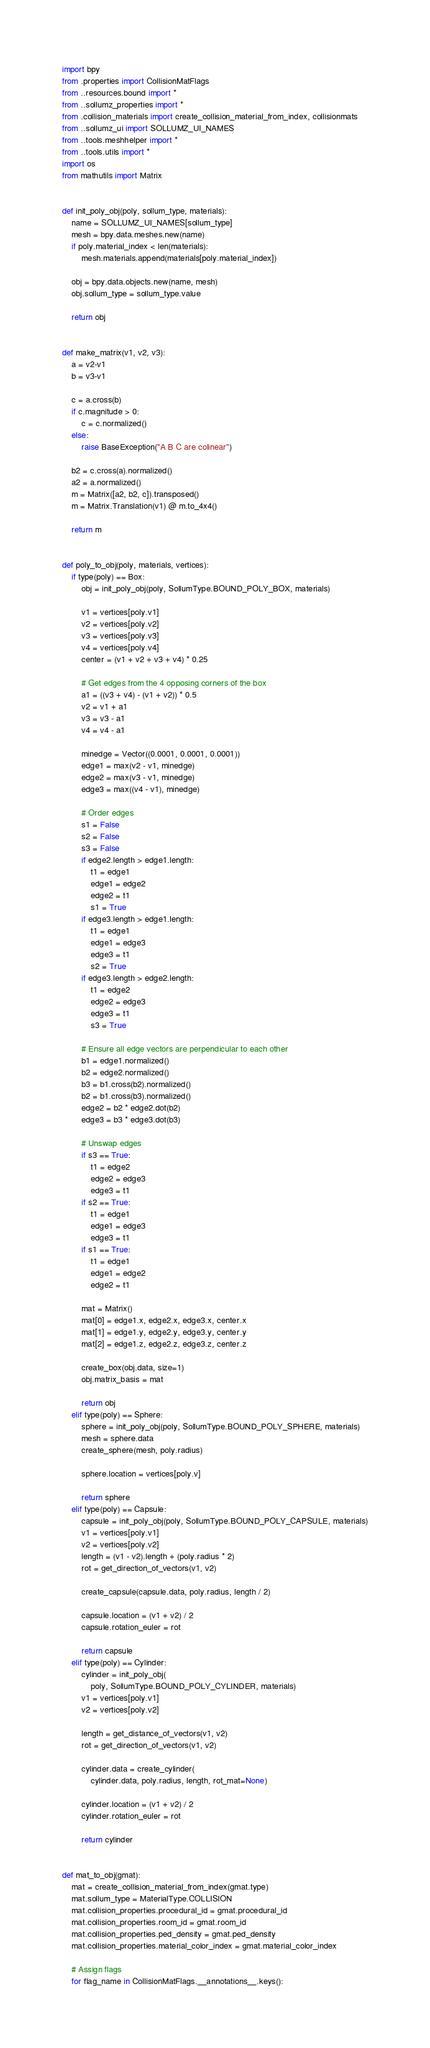<code> <loc_0><loc_0><loc_500><loc_500><_Python_>import bpy
from .properties import CollisionMatFlags
from ..resources.bound import *
from ..sollumz_properties import *
from .collision_materials import create_collision_material_from_index, collisionmats
from ..sollumz_ui import SOLLUMZ_UI_NAMES
from ..tools.meshhelper import *
from ..tools.utils import *
import os
from mathutils import Matrix


def init_poly_obj(poly, sollum_type, materials):
    name = SOLLUMZ_UI_NAMES[sollum_type]
    mesh = bpy.data.meshes.new(name)
    if poly.material_index < len(materials):
        mesh.materials.append(materials[poly.material_index])

    obj = bpy.data.objects.new(name, mesh)
    obj.sollum_type = sollum_type.value

    return obj


def make_matrix(v1, v2, v3):
    a = v2-v1
    b = v3-v1

    c = a.cross(b)
    if c.magnitude > 0:
        c = c.normalized()
    else:
        raise BaseException("A B C are colinear")

    b2 = c.cross(a).normalized()
    a2 = a.normalized()
    m = Matrix([a2, b2, c]).transposed()
    m = Matrix.Translation(v1) @ m.to_4x4()

    return m


def poly_to_obj(poly, materials, vertices):
    if type(poly) == Box:
        obj = init_poly_obj(poly, SollumType.BOUND_POLY_BOX, materials)

        v1 = vertices[poly.v1]
        v2 = vertices[poly.v2]
        v3 = vertices[poly.v3]
        v4 = vertices[poly.v4]
        center = (v1 + v2 + v3 + v4) * 0.25

        # Get edges from the 4 opposing corners of the box
        a1 = ((v3 + v4) - (v1 + v2)) * 0.5
        v2 = v1 + a1
        v3 = v3 - a1
        v4 = v4 - a1

        minedge = Vector((0.0001, 0.0001, 0.0001))
        edge1 = max(v2 - v1, minedge)
        edge2 = max(v3 - v1, minedge)
        edge3 = max((v4 - v1), minedge)

        # Order edges
        s1 = False
        s2 = False
        s3 = False
        if edge2.length > edge1.length:
            t1 = edge1
            edge1 = edge2
            edge2 = t1
            s1 = True
        if edge3.length > edge1.length:
            t1 = edge1
            edge1 = edge3
            edge3 = t1
            s2 = True
        if edge3.length > edge2.length:
            t1 = edge2
            edge2 = edge3
            edge3 = t1
            s3 = True

        # Ensure all edge vectors are perpendicular to each other
        b1 = edge1.normalized()
        b2 = edge2.normalized()
        b3 = b1.cross(b2).normalized()
        b2 = b1.cross(b3).normalized()
        edge2 = b2 * edge2.dot(b2)
        edge3 = b3 * edge3.dot(b3)

        # Unswap edges
        if s3 == True:
            t1 = edge2
            edge2 = edge3
            edge3 = t1
        if s2 == True:
            t1 = edge1
            edge1 = edge3
            edge3 = t1
        if s1 == True:
            t1 = edge1
            edge1 = edge2
            edge2 = t1

        mat = Matrix()
        mat[0] = edge1.x, edge2.x, edge3.x, center.x
        mat[1] = edge1.y, edge2.y, edge3.y, center.y
        mat[2] = edge1.z, edge2.z, edge3.z, center.z

        create_box(obj.data, size=1)
        obj.matrix_basis = mat

        return obj
    elif type(poly) == Sphere:
        sphere = init_poly_obj(poly, SollumType.BOUND_POLY_SPHERE, materials)
        mesh = sphere.data
        create_sphere(mesh, poly.radius)

        sphere.location = vertices[poly.v]

        return sphere
    elif type(poly) == Capsule:
        capsule = init_poly_obj(poly, SollumType.BOUND_POLY_CAPSULE, materials)
        v1 = vertices[poly.v1]
        v2 = vertices[poly.v2]
        length = (v1 - v2).length + (poly.radius * 2)
        rot = get_direction_of_vectors(v1, v2)

        create_capsule(capsule.data, poly.radius, length / 2)

        capsule.location = (v1 + v2) / 2
        capsule.rotation_euler = rot

        return capsule
    elif type(poly) == Cylinder:
        cylinder = init_poly_obj(
            poly, SollumType.BOUND_POLY_CYLINDER, materials)
        v1 = vertices[poly.v1]
        v2 = vertices[poly.v2]

        length = get_distance_of_vectors(v1, v2)
        rot = get_direction_of_vectors(v1, v2)

        cylinder.data = create_cylinder(
            cylinder.data, poly.radius, length, rot_mat=None)

        cylinder.location = (v1 + v2) / 2
        cylinder.rotation_euler = rot

        return cylinder


def mat_to_obj(gmat):
    mat = create_collision_material_from_index(gmat.type)
    mat.sollum_type = MaterialType.COLLISION
    mat.collision_properties.procedural_id = gmat.procedural_id
    mat.collision_properties.room_id = gmat.room_id
    mat.collision_properties.ped_density = gmat.ped_density
    mat.collision_properties.material_color_index = gmat.material_color_index

    # Assign flags
    for flag_name in CollisionMatFlags.__annotations__.keys():</code> 